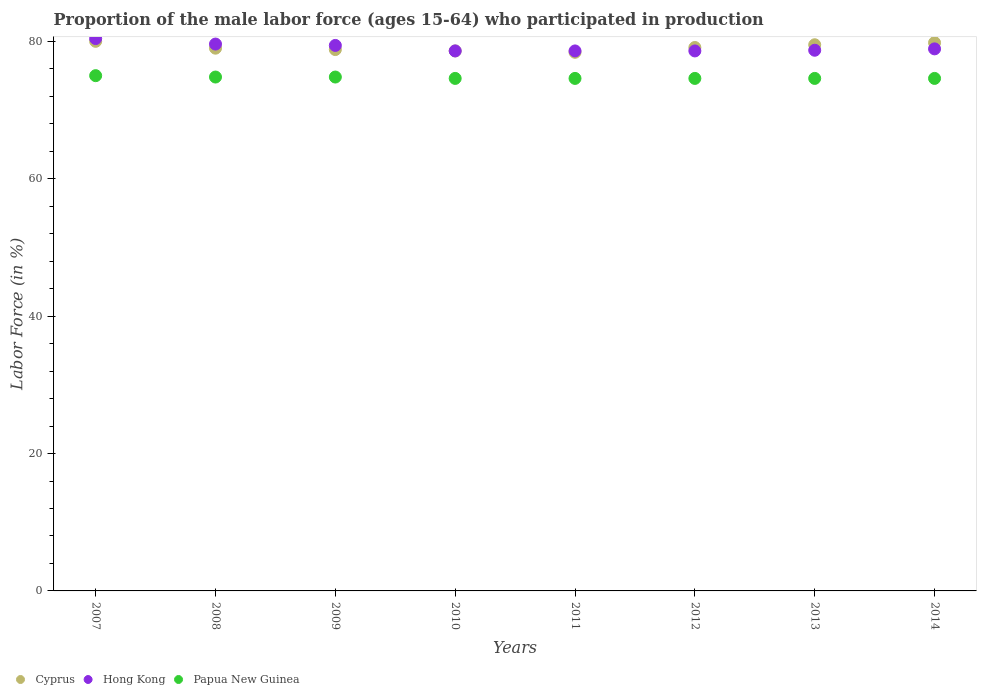What is the proportion of the male labor force who participated in production in Cyprus in 2010?
Keep it short and to the point. 78.6. Across all years, what is the minimum proportion of the male labor force who participated in production in Papua New Guinea?
Keep it short and to the point. 74.6. In which year was the proportion of the male labor force who participated in production in Hong Kong maximum?
Give a very brief answer. 2007. What is the total proportion of the male labor force who participated in production in Cyprus in the graph?
Provide a short and direct response. 633.2. What is the difference between the proportion of the male labor force who participated in production in Cyprus in 2007 and that in 2009?
Your answer should be very brief. 1.2. What is the difference between the proportion of the male labor force who participated in production in Papua New Guinea in 2011 and the proportion of the male labor force who participated in production in Cyprus in 2007?
Offer a very short reply. -5.4. What is the average proportion of the male labor force who participated in production in Cyprus per year?
Offer a very short reply. 79.15. In the year 2008, what is the difference between the proportion of the male labor force who participated in production in Hong Kong and proportion of the male labor force who participated in production in Papua New Guinea?
Keep it short and to the point. 4.8. What is the ratio of the proportion of the male labor force who participated in production in Cyprus in 2010 to that in 2012?
Provide a succinct answer. 0.99. Is the proportion of the male labor force who participated in production in Papua New Guinea in 2011 less than that in 2014?
Provide a succinct answer. No. Is the difference between the proportion of the male labor force who participated in production in Hong Kong in 2007 and 2011 greater than the difference between the proportion of the male labor force who participated in production in Papua New Guinea in 2007 and 2011?
Make the answer very short. Yes. What is the difference between the highest and the second highest proportion of the male labor force who participated in production in Papua New Guinea?
Provide a succinct answer. 0.2. What is the difference between the highest and the lowest proportion of the male labor force who participated in production in Cyprus?
Provide a succinct answer. 1.6. Is the proportion of the male labor force who participated in production in Cyprus strictly greater than the proportion of the male labor force who participated in production in Hong Kong over the years?
Keep it short and to the point. No. Is the proportion of the male labor force who participated in production in Cyprus strictly less than the proportion of the male labor force who participated in production in Papua New Guinea over the years?
Provide a succinct answer. No. What is the difference between two consecutive major ticks on the Y-axis?
Your answer should be very brief. 20. Are the values on the major ticks of Y-axis written in scientific E-notation?
Offer a terse response. No. Where does the legend appear in the graph?
Keep it short and to the point. Bottom left. How many legend labels are there?
Your answer should be compact. 3. What is the title of the graph?
Keep it short and to the point. Proportion of the male labor force (ages 15-64) who participated in production. What is the label or title of the X-axis?
Offer a very short reply. Years. What is the Labor Force (in %) in Hong Kong in 2007?
Your answer should be very brief. 80.4. What is the Labor Force (in %) of Cyprus in 2008?
Your answer should be compact. 79. What is the Labor Force (in %) of Hong Kong in 2008?
Provide a succinct answer. 79.6. What is the Labor Force (in %) in Papua New Guinea in 2008?
Make the answer very short. 74.8. What is the Labor Force (in %) of Cyprus in 2009?
Provide a succinct answer. 78.8. What is the Labor Force (in %) of Hong Kong in 2009?
Make the answer very short. 79.4. What is the Labor Force (in %) in Papua New Guinea in 2009?
Provide a short and direct response. 74.8. What is the Labor Force (in %) of Cyprus in 2010?
Your answer should be very brief. 78.6. What is the Labor Force (in %) in Hong Kong in 2010?
Provide a short and direct response. 78.6. What is the Labor Force (in %) in Papua New Guinea in 2010?
Provide a succinct answer. 74.6. What is the Labor Force (in %) in Cyprus in 2011?
Offer a terse response. 78.4. What is the Labor Force (in %) of Hong Kong in 2011?
Make the answer very short. 78.6. What is the Labor Force (in %) of Papua New Guinea in 2011?
Your answer should be compact. 74.6. What is the Labor Force (in %) in Cyprus in 2012?
Provide a short and direct response. 79.1. What is the Labor Force (in %) in Hong Kong in 2012?
Your answer should be very brief. 78.6. What is the Labor Force (in %) in Papua New Guinea in 2012?
Your answer should be compact. 74.6. What is the Labor Force (in %) of Cyprus in 2013?
Your answer should be compact. 79.5. What is the Labor Force (in %) of Hong Kong in 2013?
Your answer should be very brief. 78.7. What is the Labor Force (in %) of Papua New Guinea in 2013?
Provide a succinct answer. 74.6. What is the Labor Force (in %) in Cyprus in 2014?
Your answer should be compact. 79.8. What is the Labor Force (in %) in Hong Kong in 2014?
Ensure brevity in your answer.  78.9. What is the Labor Force (in %) of Papua New Guinea in 2014?
Ensure brevity in your answer.  74.6. Across all years, what is the maximum Labor Force (in %) of Cyprus?
Provide a short and direct response. 80. Across all years, what is the maximum Labor Force (in %) of Hong Kong?
Give a very brief answer. 80.4. Across all years, what is the minimum Labor Force (in %) of Cyprus?
Ensure brevity in your answer.  78.4. Across all years, what is the minimum Labor Force (in %) in Hong Kong?
Your response must be concise. 78.6. Across all years, what is the minimum Labor Force (in %) of Papua New Guinea?
Provide a short and direct response. 74.6. What is the total Labor Force (in %) in Cyprus in the graph?
Provide a short and direct response. 633.2. What is the total Labor Force (in %) in Hong Kong in the graph?
Ensure brevity in your answer.  632.8. What is the total Labor Force (in %) of Papua New Guinea in the graph?
Your answer should be very brief. 597.6. What is the difference between the Labor Force (in %) in Cyprus in 2007 and that in 2008?
Offer a terse response. 1. What is the difference between the Labor Force (in %) of Cyprus in 2007 and that in 2009?
Make the answer very short. 1.2. What is the difference between the Labor Force (in %) in Hong Kong in 2007 and that in 2009?
Offer a very short reply. 1. What is the difference between the Labor Force (in %) of Papua New Guinea in 2007 and that in 2009?
Ensure brevity in your answer.  0.2. What is the difference between the Labor Force (in %) in Cyprus in 2007 and that in 2010?
Make the answer very short. 1.4. What is the difference between the Labor Force (in %) of Hong Kong in 2007 and that in 2010?
Ensure brevity in your answer.  1.8. What is the difference between the Labor Force (in %) of Cyprus in 2007 and that in 2011?
Your answer should be very brief. 1.6. What is the difference between the Labor Force (in %) in Hong Kong in 2007 and that in 2011?
Provide a short and direct response. 1.8. What is the difference between the Labor Force (in %) in Cyprus in 2007 and that in 2012?
Your answer should be compact. 0.9. What is the difference between the Labor Force (in %) in Hong Kong in 2007 and that in 2012?
Offer a very short reply. 1.8. What is the difference between the Labor Force (in %) of Papua New Guinea in 2007 and that in 2012?
Provide a succinct answer. 0.4. What is the difference between the Labor Force (in %) in Cyprus in 2007 and that in 2013?
Provide a succinct answer. 0.5. What is the difference between the Labor Force (in %) of Hong Kong in 2007 and that in 2013?
Give a very brief answer. 1.7. What is the difference between the Labor Force (in %) in Hong Kong in 2007 and that in 2014?
Offer a very short reply. 1.5. What is the difference between the Labor Force (in %) of Papua New Guinea in 2007 and that in 2014?
Provide a short and direct response. 0.4. What is the difference between the Labor Force (in %) of Cyprus in 2008 and that in 2009?
Offer a terse response. 0.2. What is the difference between the Labor Force (in %) of Hong Kong in 2008 and that in 2009?
Provide a succinct answer. 0.2. What is the difference between the Labor Force (in %) of Hong Kong in 2008 and that in 2010?
Give a very brief answer. 1. What is the difference between the Labor Force (in %) in Papua New Guinea in 2008 and that in 2011?
Keep it short and to the point. 0.2. What is the difference between the Labor Force (in %) of Hong Kong in 2008 and that in 2012?
Keep it short and to the point. 1. What is the difference between the Labor Force (in %) of Papua New Guinea in 2008 and that in 2012?
Your answer should be very brief. 0.2. What is the difference between the Labor Force (in %) in Cyprus in 2008 and that in 2013?
Keep it short and to the point. -0.5. What is the difference between the Labor Force (in %) in Hong Kong in 2008 and that in 2014?
Offer a terse response. 0.7. What is the difference between the Labor Force (in %) of Papua New Guinea in 2008 and that in 2014?
Your answer should be compact. 0.2. What is the difference between the Labor Force (in %) of Cyprus in 2009 and that in 2010?
Your response must be concise. 0.2. What is the difference between the Labor Force (in %) in Hong Kong in 2009 and that in 2010?
Your response must be concise. 0.8. What is the difference between the Labor Force (in %) in Papua New Guinea in 2009 and that in 2010?
Make the answer very short. 0.2. What is the difference between the Labor Force (in %) in Hong Kong in 2009 and that in 2011?
Your answer should be very brief. 0.8. What is the difference between the Labor Force (in %) in Papua New Guinea in 2009 and that in 2011?
Your answer should be very brief. 0.2. What is the difference between the Labor Force (in %) in Papua New Guinea in 2009 and that in 2012?
Keep it short and to the point. 0.2. What is the difference between the Labor Force (in %) in Hong Kong in 2009 and that in 2013?
Your answer should be very brief. 0.7. What is the difference between the Labor Force (in %) in Hong Kong in 2009 and that in 2014?
Keep it short and to the point. 0.5. What is the difference between the Labor Force (in %) of Papua New Guinea in 2009 and that in 2014?
Keep it short and to the point. 0.2. What is the difference between the Labor Force (in %) of Hong Kong in 2010 and that in 2011?
Your answer should be very brief. 0. What is the difference between the Labor Force (in %) in Cyprus in 2010 and that in 2012?
Keep it short and to the point. -0.5. What is the difference between the Labor Force (in %) of Hong Kong in 2010 and that in 2012?
Make the answer very short. 0. What is the difference between the Labor Force (in %) in Hong Kong in 2010 and that in 2013?
Ensure brevity in your answer.  -0.1. What is the difference between the Labor Force (in %) of Cyprus in 2010 and that in 2014?
Your answer should be compact. -1.2. What is the difference between the Labor Force (in %) of Papua New Guinea in 2010 and that in 2014?
Your answer should be compact. 0. What is the difference between the Labor Force (in %) of Cyprus in 2011 and that in 2012?
Your response must be concise. -0.7. What is the difference between the Labor Force (in %) in Hong Kong in 2011 and that in 2012?
Your answer should be very brief. 0. What is the difference between the Labor Force (in %) in Papua New Guinea in 2011 and that in 2012?
Offer a terse response. 0. What is the difference between the Labor Force (in %) in Cyprus in 2011 and that in 2013?
Your answer should be compact. -1.1. What is the difference between the Labor Force (in %) of Papua New Guinea in 2011 and that in 2013?
Offer a very short reply. 0. What is the difference between the Labor Force (in %) of Papua New Guinea in 2011 and that in 2014?
Keep it short and to the point. 0. What is the difference between the Labor Force (in %) in Papua New Guinea in 2012 and that in 2013?
Provide a short and direct response. 0. What is the difference between the Labor Force (in %) in Hong Kong in 2012 and that in 2014?
Offer a terse response. -0.3. What is the difference between the Labor Force (in %) of Papua New Guinea in 2012 and that in 2014?
Provide a succinct answer. 0. What is the difference between the Labor Force (in %) in Cyprus in 2013 and that in 2014?
Give a very brief answer. -0.3. What is the difference between the Labor Force (in %) in Hong Kong in 2007 and the Labor Force (in %) in Papua New Guinea in 2008?
Your answer should be compact. 5.6. What is the difference between the Labor Force (in %) in Cyprus in 2007 and the Labor Force (in %) in Hong Kong in 2009?
Keep it short and to the point. 0.6. What is the difference between the Labor Force (in %) of Cyprus in 2007 and the Labor Force (in %) of Papua New Guinea in 2009?
Your response must be concise. 5.2. What is the difference between the Labor Force (in %) in Hong Kong in 2007 and the Labor Force (in %) in Papua New Guinea in 2009?
Your answer should be compact. 5.6. What is the difference between the Labor Force (in %) in Cyprus in 2007 and the Labor Force (in %) in Papua New Guinea in 2011?
Your response must be concise. 5.4. What is the difference between the Labor Force (in %) in Cyprus in 2007 and the Labor Force (in %) in Hong Kong in 2012?
Your answer should be very brief. 1.4. What is the difference between the Labor Force (in %) in Hong Kong in 2007 and the Labor Force (in %) in Papua New Guinea in 2012?
Your response must be concise. 5.8. What is the difference between the Labor Force (in %) of Cyprus in 2007 and the Labor Force (in %) of Papua New Guinea in 2013?
Your answer should be compact. 5.4. What is the difference between the Labor Force (in %) of Hong Kong in 2007 and the Labor Force (in %) of Papua New Guinea in 2014?
Provide a succinct answer. 5.8. What is the difference between the Labor Force (in %) of Cyprus in 2008 and the Labor Force (in %) of Papua New Guinea in 2009?
Your response must be concise. 4.2. What is the difference between the Labor Force (in %) in Hong Kong in 2008 and the Labor Force (in %) in Papua New Guinea in 2009?
Provide a succinct answer. 4.8. What is the difference between the Labor Force (in %) of Hong Kong in 2008 and the Labor Force (in %) of Papua New Guinea in 2010?
Provide a short and direct response. 5. What is the difference between the Labor Force (in %) of Cyprus in 2008 and the Labor Force (in %) of Hong Kong in 2011?
Offer a terse response. 0.4. What is the difference between the Labor Force (in %) in Hong Kong in 2008 and the Labor Force (in %) in Papua New Guinea in 2011?
Keep it short and to the point. 5. What is the difference between the Labor Force (in %) of Cyprus in 2008 and the Labor Force (in %) of Papua New Guinea in 2012?
Your answer should be very brief. 4.4. What is the difference between the Labor Force (in %) of Cyprus in 2008 and the Labor Force (in %) of Papua New Guinea in 2013?
Offer a terse response. 4.4. What is the difference between the Labor Force (in %) of Cyprus in 2008 and the Labor Force (in %) of Hong Kong in 2014?
Make the answer very short. 0.1. What is the difference between the Labor Force (in %) of Cyprus in 2008 and the Labor Force (in %) of Papua New Guinea in 2014?
Provide a short and direct response. 4.4. What is the difference between the Labor Force (in %) of Hong Kong in 2008 and the Labor Force (in %) of Papua New Guinea in 2014?
Offer a very short reply. 5. What is the difference between the Labor Force (in %) in Cyprus in 2009 and the Labor Force (in %) in Hong Kong in 2010?
Provide a short and direct response. 0.2. What is the difference between the Labor Force (in %) in Cyprus in 2009 and the Labor Force (in %) in Hong Kong in 2011?
Offer a terse response. 0.2. What is the difference between the Labor Force (in %) in Cyprus in 2009 and the Labor Force (in %) in Papua New Guinea in 2011?
Provide a succinct answer. 4.2. What is the difference between the Labor Force (in %) of Hong Kong in 2009 and the Labor Force (in %) of Papua New Guinea in 2011?
Offer a very short reply. 4.8. What is the difference between the Labor Force (in %) in Cyprus in 2009 and the Labor Force (in %) in Papua New Guinea in 2012?
Offer a terse response. 4.2. What is the difference between the Labor Force (in %) of Hong Kong in 2009 and the Labor Force (in %) of Papua New Guinea in 2012?
Keep it short and to the point. 4.8. What is the difference between the Labor Force (in %) of Cyprus in 2009 and the Labor Force (in %) of Papua New Guinea in 2013?
Provide a succinct answer. 4.2. What is the difference between the Labor Force (in %) of Cyprus in 2009 and the Labor Force (in %) of Hong Kong in 2014?
Your answer should be compact. -0.1. What is the difference between the Labor Force (in %) in Cyprus in 2009 and the Labor Force (in %) in Papua New Guinea in 2014?
Your answer should be very brief. 4.2. What is the difference between the Labor Force (in %) of Hong Kong in 2009 and the Labor Force (in %) of Papua New Guinea in 2014?
Offer a very short reply. 4.8. What is the difference between the Labor Force (in %) in Hong Kong in 2010 and the Labor Force (in %) in Papua New Guinea in 2012?
Give a very brief answer. 4. What is the difference between the Labor Force (in %) in Cyprus in 2010 and the Labor Force (in %) in Hong Kong in 2013?
Give a very brief answer. -0.1. What is the difference between the Labor Force (in %) of Cyprus in 2011 and the Labor Force (in %) of Papua New Guinea in 2012?
Ensure brevity in your answer.  3.8. What is the difference between the Labor Force (in %) in Hong Kong in 2011 and the Labor Force (in %) in Papua New Guinea in 2013?
Make the answer very short. 4. What is the difference between the Labor Force (in %) of Cyprus in 2011 and the Labor Force (in %) of Hong Kong in 2014?
Offer a very short reply. -0.5. What is the difference between the Labor Force (in %) in Cyprus in 2011 and the Labor Force (in %) in Papua New Guinea in 2014?
Your response must be concise. 3.8. What is the difference between the Labor Force (in %) of Cyprus in 2012 and the Labor Force (in %) of Hong Kong in 2013?
Your response must be concise. 0.4. What is the difference between the Labor Force (in %) of Hong Kong in 2012 and the Labor Force (in %) of Papua New Guinea in 2013?
Provide a succinct answer. 4. What is the difference between the Labor Force (in %) in Hong Kong in 2012 and the Labor Force (in %) in Papua New Guinea in 2014?
Provide a succinct answer. 4. What is the average Labor Force (in %) of Cyprus per year?
Your answer should be compact. 79.15. What is the average Labor Force (in %) of Hong Kong per year?
Offer a terse response. 79.1. What is the average Labor Force (in %) in Papua New Guinea per year?
Provide a short and direct response. 74.7. In the year 2007, what is the difference between the Labor Force (in %) in Cyprus and Labor Force (in %) in Hong Kong?
Provide a succinct answer. -0.4. In the year 2007, what is the difference between the Labor Force (in %) of Cyprus and Labor Force (in %) of Papua New Guinea?
Ensure brevity in your answer.  5. In the year 2007, what is the difference between the Labor Force (in %) in Hong Kong and Labor Force (in %) in Papua New Guinea?
Provide a succinct answer. 5.4. In the year 2009, what is the difference between the Labor Force (in %) of Cyprus and Labor Force (in %) of Hong Kong?
Offer a very short reply. -0.6. In the year 2009, what is the difference between the Labor Force (in %) of Cyprus and Labor Force (in %) of Papua New Guinea?
Offer a very short reply. 4. In the year 2009, what is the difference between the Labor Force (in %) in Hong Kong and Labor Force (in %) in Papua New Guinea?
Your answer should be compact. 4.6. In the year 2010, what is the difference between the Labor Force (in %) in Cyprus and Labor Force (in %) in Hong Kong?
Provide a short and direct response. 0. In the year 2011, what is the difference between the Labor Force (in %) of Cyprus and Labor Force (in %) of Papua New Guinea?
Your answer should be compact. 3.8. In the year 2012, what is the difference between the Labor Force (in %) in Cyprus and Labor Force (in %) in Papua New Guinea?
Your response must be concise. 4.5. In the year 2012, what is the difference between the Labor Force (in %) in Hong Kong and Labor Force (in %) in Papua New Guinea?
Ensure brevity in your answer.  4. In the year 2013, what is the difference between the Labor Force (in %) in Cyprus and Labor Force (in %) in Hong Kong?
Give a very brief answer. 0.8. In the year 2013, what is the difference between the Labor Force (in %) in Cyprus and Labor Force (in %) in Papua New Guinea?
Keep it short and to the point. 4.9. In the year 2014, what is the difference between the Labor Force (in %) in Cyprus and Labor Force (in %) in Hong Kong?
Keep it short and to the point. 0.9. What is the ratio of the Labor Force (in %) in Cyprus in 2007 to that in 2008?
Give a very brief answer. 1.01. What is the ratio of the Labor Force (in %) in Cyprus in 2007 to that in 2009?
Provide a short and direct response. 1.02. What is the ratio of the Labor Force (in %) in Hong Kong in 2007 to that in 2009?
Make the answer very short. 1.01. What is the ratio of the Labor Force (in %) of Papua New Guinea in 2007 to that in 2009?
Make the answer very short. 1. What is the ratio of the Labor Force (in %) of Cyprus in 2007 to that in 2010?
Your answer should be compact. 1.02. What is the ratio of the Labor Force (in %) of Hong Kong in 2007 to that in 2010?
Provide a succinct answer. 1.02. What is the ratio of the Labor Force (in %) of Papua New Guinea in 2007 to that in 2010?
Your response must be concise. 1.01. What is the ratio of the Labor Force (in %) in Cyprus in 2007 to that in 2011?
Provide a short and direct response. 1.02. What is the ratio of the Labor Force (in %) in Hong Kong in 2007 to that in 2011?
Your answer should be compact. 1.02. What is the ratio of the Labor Force (in %) in Papua New Guinea in 2007 to that in 2011?
Keep it short and to the point. 1.01. What is the ratio of the Labor Force (in %) in Cyprus in 2007 to that in 2012?
Provide a short and direct response. 1.01. What is the ratio of the Labor Force (in %) in Hong Kong in 2007 to that in 2012?
Provide a short and direct response. 1.02. What is the ratio of the Labor Force (in %) in Papua New Guinea in 2007 to that in 2012?
Your response must be concise. 1.01. What is the ratio of the Labor Force (in %) in Hong Kong in 2007 to that in 2013?
Provide a short and direct response. 1.02. What is the ratio of the Labor Force (in %) in Papua New Guinea in 2007 to that in 2013?
Offer a very short reply. 1.01. What is the ratio of the Labor Force (in %) in Papua New Guinea in 2007 to that in 2014?
Provide a succinct answer. 1.01. What is the ratio of the Labor Force (in %) in Hong Kong in 2008 to that in 2009?
Provide a succinct answer. 1. What is the ratio of the Labor Force (in %) of Cyprus in 2008 to that in 2010?
Your answer should be very brief. 1.01. What is the ratio of the Labor Force (in %) of Hong Kong in 2008 to that in 2010?
Offer a terse response. 1.01. What is the ratio of the Labor Force (in %) in Papua New Guinea in 2008 to that in 2010?
Ensure brevity in your answer.  1. What is the ratio of the Labor Force (in %) of Cyprus in 2008 to that in 2011?
Your answer should be compact. 1.01. What is the ratio of the Labor Force (in %) of Hong Kong in 2008 to that in 2011?
Your answer should be very brief. 1.01. What is the ratio of the Labor Force (in %) of Hong Kong in 2008 to that in 2012?
Your answer should be very brief. 1.01. What is the ratio of the Labor Force (in %) of Papua New Guinea in 2008 to that in 2012?
Ensure brevity in your answer.  1. What is the ratio of the Labor Force (in %) in Cyprus in 2008 to that in 2013?
Offer a terse response. 0.99. What is the ratio of the Labor Force (in %) of Hong Kong in 2008 to that in 2013?
Keep it short and to the point. 1.01. What is the ratio of the Labor Force (in %) of Hong Kong in 2008 to that in 2014?
Provide a succinct answer. 1.01. What is the ratio of the Labor Force (in %) of Papua New Guinea in 2008 to that in 2014?
Your response must be concise. 1. What is the ratio of the Labor Force (in %) of Cyprus in 2009 to that in 2010?
Provide a short and direct response. 1. What is the ratio of the Labor Force (in %) of Hong Kong in 2009 to that in 2010?
Keep it short and to the point. 1.01. What is the ratio of the Labor Force (in %) of Papua New Guinea in 2009 to that in 2010?
Your response must be concise. 1. What is the ratio of the Labor Force (in %) of Cyprus in 2009 to that in 2011?
Your response must be concise. 1.01. What is the ratio of the Labor Force (in %) in Hong Kong in 2009 to that in 2011?
Give a very brief answer. 1.01. What is the ratio of the Labor Force (in %) of Papua New Guinea in 2009 to that in 2011?
Keep it short and to the point. 1. What is the ratio of the Labor Force (in %) of Cyprus in 2009 to that in 2012?
Give a very brief answer. 1. What is the ratio of the Labor Force (in %) of Hong Kong in 2009 to that in 2012?
Provide a succinct answer. 1.01. What is the ratio of the Labor Force (in %) in Hong Kong in 2009 to that in 2013?
Make the answer very short. 1.01. What is the ratio of the Labor Force (in %) in Cyprus in 2009 to that in 2014?
Offer a very short reply. 0.99. What is the ratio of the Labor Force (in %) in Hong Kong in 2009 to that in 2014?
Your response must be concise. 1.01. What is the ratio of the Labor Force (in %) in Papua New Guinea in 2010 to that in 2011?
Your response must be concise. 1. What is the ratio of the Labor Force (in %) of Hong Kong in 2010 to that in 2012?
Offer a terse response. 1. What is the ratio of the Labor Force (in %) of Cyprus in 2010 to that in 2013?
Provide a short and direct response. 0.99. What is the ratio of the Labor Force (in %) in Papua New Guinea in 2010 to that in 2013?
Provide a short and direct response. 1. What is the ratio of the Labor Force (in %) in Hong Kong in 2010 to that in 2014?
Give a very brief answer. 1. What is the ratio of the Labor Force (in %) in Hong Kong in 2011 to that in 2012?
Keep it short and to the point. 1. What is the ratio of the Labor Force (in %) in Papua New Guinea in 2011 to that in 2012?
Provide a succinct answer. 1. What is the ratio of the Labor Force (in %) in Cyprus in 2011 to that in 2013?
Provide a succinct answer. 0.99. What is the ratio of the Labor Force (in %) of Hong Kong in 2011 to that in 2013?
Provide a succinct answer. 1. What is the ratio of the Labor Force (in %) of Cyprus in 2011 to that in 2014?
Offer a terse response. 0.98. What is the ratio of the Labor Force (in %) of Papua New Guinea in 2011 to that in 2014?
Make the answer very short. 1. What is the ratio of the Labor Force (in %) of Hong Kong in 2012 to that in 2013?
Keep it short and to the point. 1. What is the ratio of the Labor Force (in %) in Papua New Guinea in 2012 to that in 2013?
Provide a short and direct response. 1. What is the ratio of the Labor Force (in %) of Cyprus in 2012 to that in 2014?
Your response must be concise. 0.99. What is the ratio of the Labor Force (in %) of Hong Kong in 2012 to that in 2014?
Offer a very short reply. 1. What is the ratio of the Labor Force (in %) in Cyprus in 2013 to that in 2014?
Give a very brief answer. 1. What is the ratio of the Labor Force (in %) in Papua New Guinea in 2013 to that in 2014?
Your response must be concise. 1. What is the difference between the highest and the second highest Labor Force (in %) of Hong Kong?
Keep it short and to the point. 0.8. 